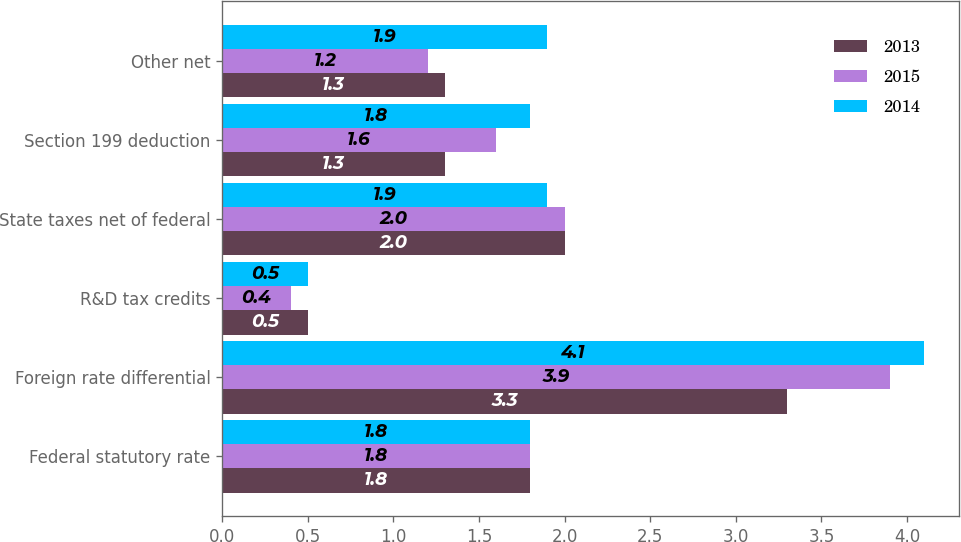Convert chart to OTSL. <chart><loc_0><loc_0><loc_500><loc_500><stacked_bar_chart><ecel><fcel>Federal statutory rate<fcel>Foreign rate differential<fcel>R&D tax credits<fcel>State taxes net of federal<fcel>Section 199 deduction<fcel>Other net<nl><fcel>2013<fcel>1.8<fcel>3.3<fcel>0.5<fcel>2<fcel>1.3<fcel>1.3<nl><fcel>2015<fcel>1.8<fcel>3.9<fcel>0.4<fcel>2<fcel>1.6<fcel>1.2<nl><fcel>2014<fcel>1.8<fcel>4.1<fcel>0.5<fcel>1.9<fcel>1.8<fcel>1.9<nl></chart> 